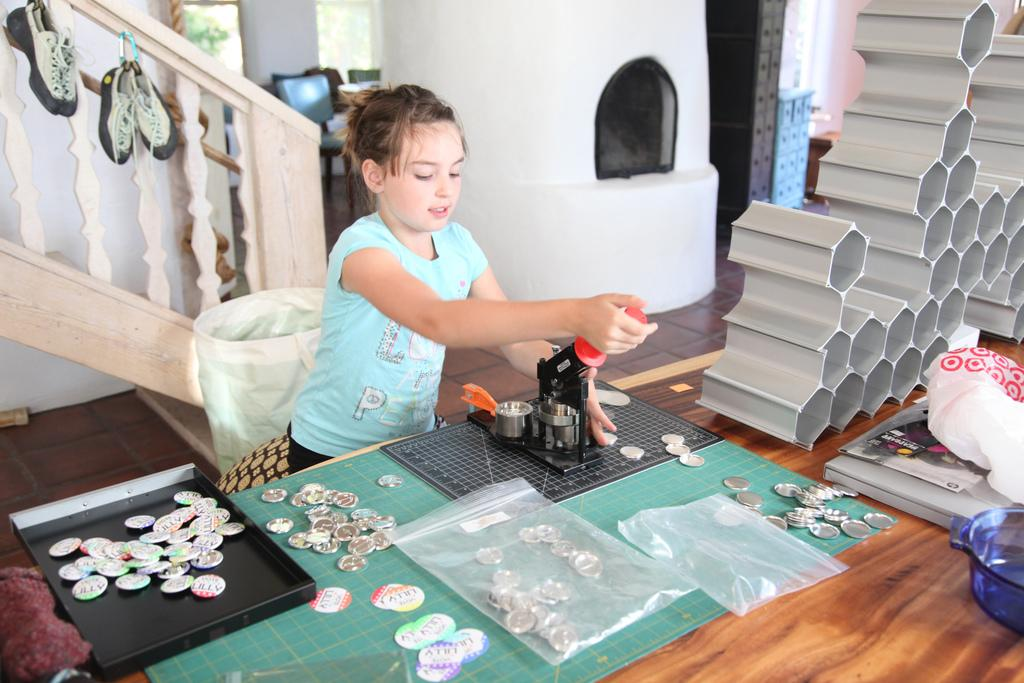Who or what is present in the image? There is a person in the image. What is the person interacting with in the image? The person is interacting with a table in the image. What is on top of the table? There are covers and coins on the table. What can be seen below the table? The floor is visible in the image. What is visible behind the table? There is a wall in the image. What type of horn can be heard in the morning in the image? There is no horn or sound present in the image, and therefore no such activity can be observed. 